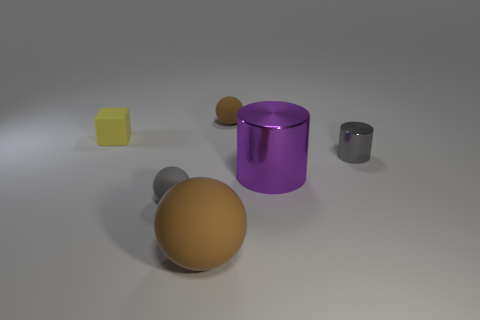Is there anything else that has the same shape as the tiny yellow object?
Give a very brief answer. No. What number of gray matte things are on the right side of the tiny rubber thing that is in front of the tiny rubber cube?
Ensure brevity in your answer.  0. Does the rubber thing on the left side of the tiny gray rubber thing have the same color as the big sphere?
Give a very brief answer. No. What number of objects are red shiny spheres or gray objects in front of the purple metallic cylinder?
Ensure brevity in your answer.  1. There is a tiny gray object behind the purple cylinder; is its shape the same as the gray thing that is to the left of the purple metallic thing?
Provide a succinct answer. No. Are there any other things that are the same color as the tiny metal cylinder?
Ensure brevity in your answer.  Yes. There is a large object that is the same material as the small gray cylinder; what is its shape?
Offer a very short reply. Cylinder. There is a ball that is both in front of the small yellow object and behind the large ball; what is it made of?
Your answer should be compact. Rubber. Does the small cylinder have the same color as the big metal object?
Ensure brevity in your answer.  No. The small object that is the same color as the small shiny cylinder is what shape?
Provide a succinct answer. Sphere. 